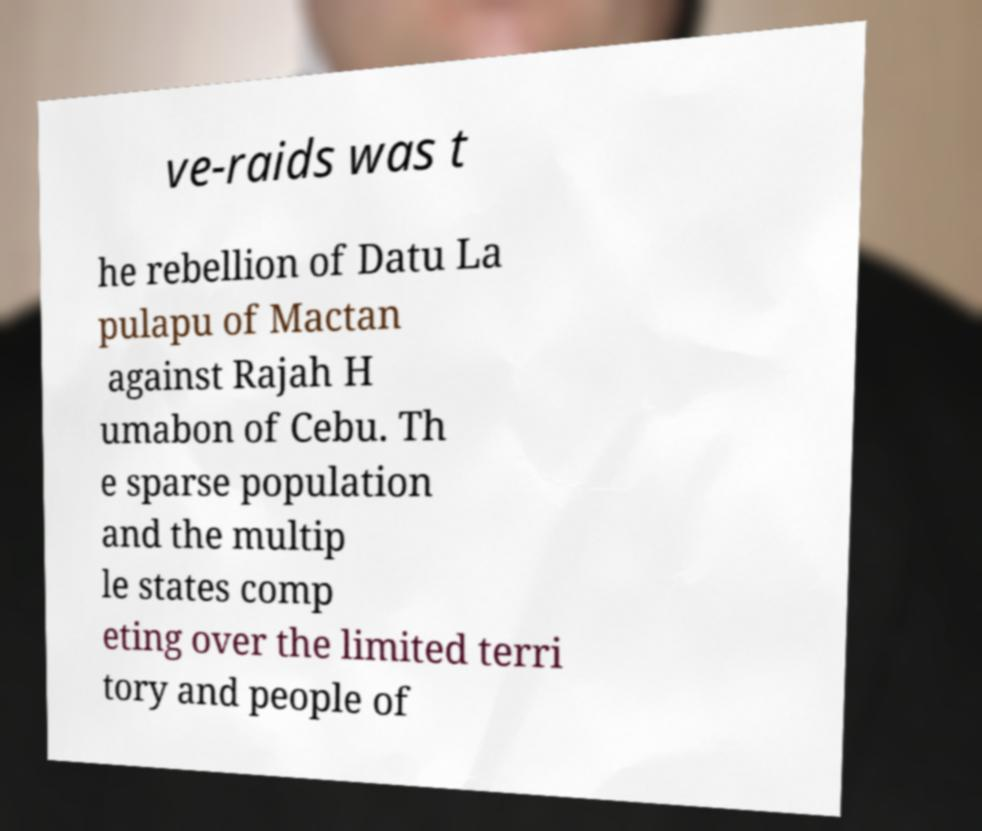Can you accurately transcribe the text from the provided image for me? ve-raids was t he rebellion of Datu La pulapu of Mactan against Rajah H umabon of Cebu. Th e sparse population and the multip le states comp eting over the limited terri tory and people of 